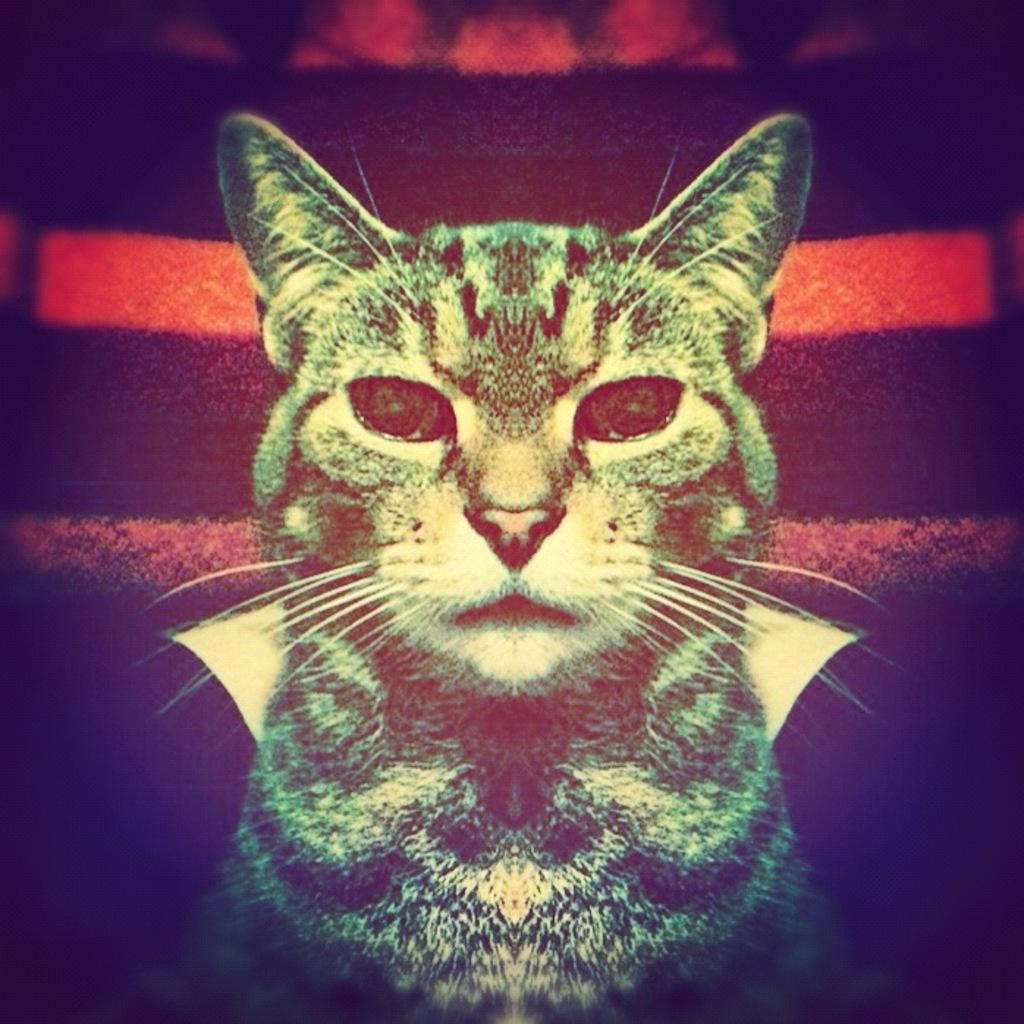What is the main subject of the image? There is a picture of a cat in the image. What can be seen in the background of the image? There appears to be a carpet in the background of the image. How many lines can be seen on the cat's back in the image? There are no lines visible on the cat's back in the image. What type of ants are crawling on the carpet in the image? There are no ants present in the image; it only features a picture of a cat and a carpet in the background. 